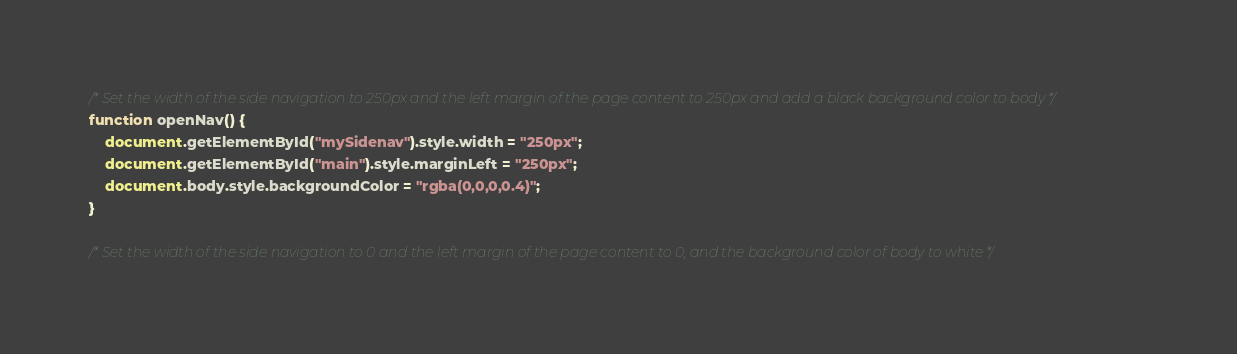<code> <loc_0><loc_0><loc_500><loc_500><_JavaScript_>/* Set the width of the side navigation to 250px and the left margin of the page content to 250px and add a black background color to body */
function openNav() {
    document.getElementById("mySidenav").style.width = "250px";
    document.getElementById("main").style.marginLeft = "250px";
    document.body.style.backgroundColor = "rgba(0,0,0,0.4)";
}

/* Set the width of the side navigation to 0 and the left margin of the page content to 0, and the background color of body to white */</code> 